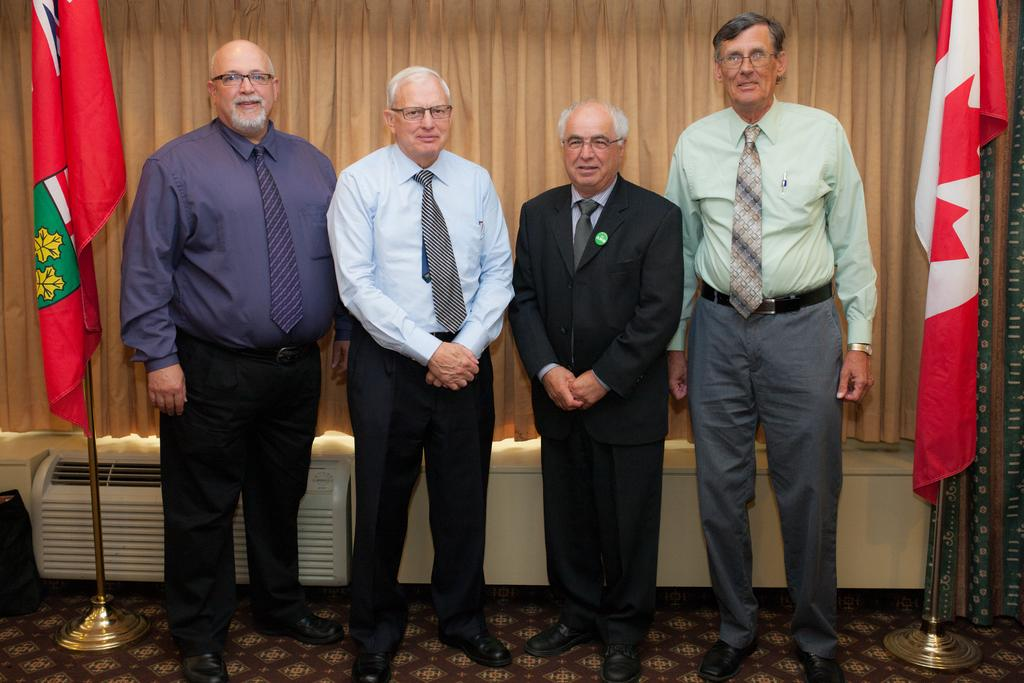How many men are in the foreground of the image? There are five men in the foreground of the image. What is the surface the men are standing on? The men are standing on a carpet. What can be seen on either side of the men? There are two flags on either side of the men. What is visible in the background of the image? There is a curtain and an AC in the background of the image. How much money is being exchanged between the men in the image? There is no indication of money or any exchange happening in the image. 